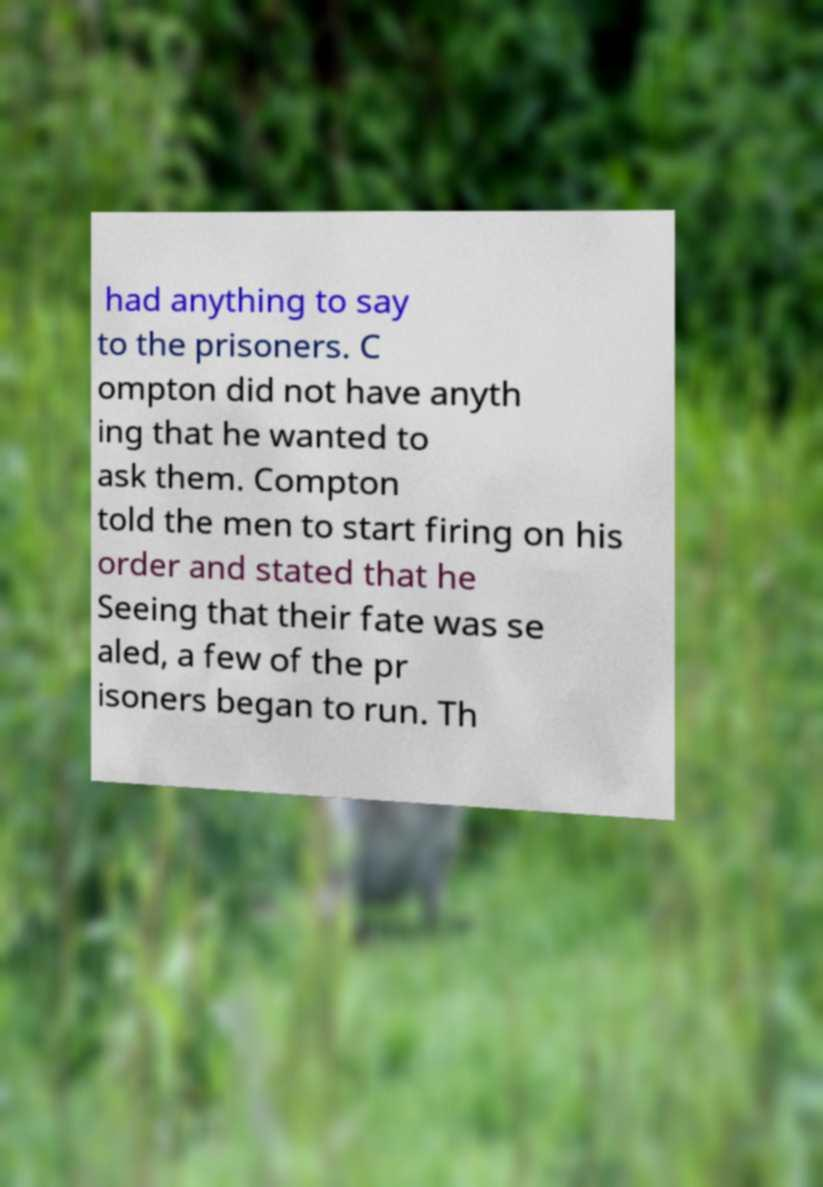For documentation purposes, I need the text within this image transcribed. Could you provide that? had anything to say to the prisoners. C ompton did not have anyth ing that he wanted to ask them. Compton told the men to start firing on his order and stated that he Seeing that their fate was se aled, a few of the pr isoners began to run. Th 